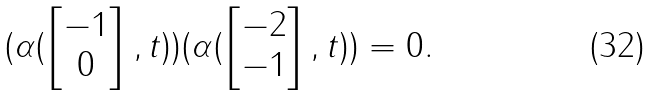Convert formula to latex. <formula><loc_0><loc_0><loc_500><loc_500>( \alpha ( \begin{bmatrix} - 1 \\ 0 \end{bmatrix} , t ) ) ( \alpha ( \begin{bmatrix} - 2 \\ - 1 \end{bmatrix} , t ) ) = 0 .</formula> 